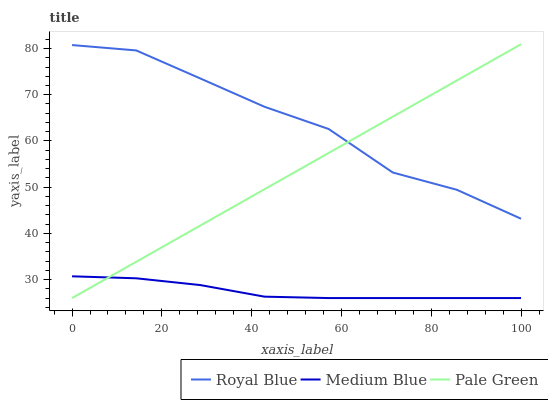Does Medium Blue have the minimum area under the curve?
Answer yes or no. Yes. Does Royal Blue have the maximum area under the curve?
Answer yes or no. Yes. Does Pale Green have the minimum area under the curve?
Answer yes or no. No. Does Pale Green have the maximum area under the curve?
Answer yes or no. No. Is Pale Green the smoothest?
Answer yes or no. Yes. Is Royal Blue the roughest?
Answer yes or no. Yes. Is Medium Blue the smoothest?
Answer yes or no. No. Is Medium Blue the roughest?
Answer yes or no. No. Does Pale Green have the lowest value?
Answer yes or no. Yes. Does Pale Green have the highest value?
Answer yes or no. Yes. Does Medium Blue have the highest value?
Answer yes or no. No. Is Medium Blue less than Royal Blue?
Answer yes or no. Yes. Is Royal Blue greater than Medium Blue?
Answer yes or no. Yes. Does Pale Green intersect Medium Blue?
Answer yes or no. Yes. Is Pale Green less than Medium Blue?
Answer yes or no. No. Is Pale Green greater than Medium Blue?
Answer yes or no. No. Does Medium Blue intersect Royal Blue?
Answer yes or no. No. 